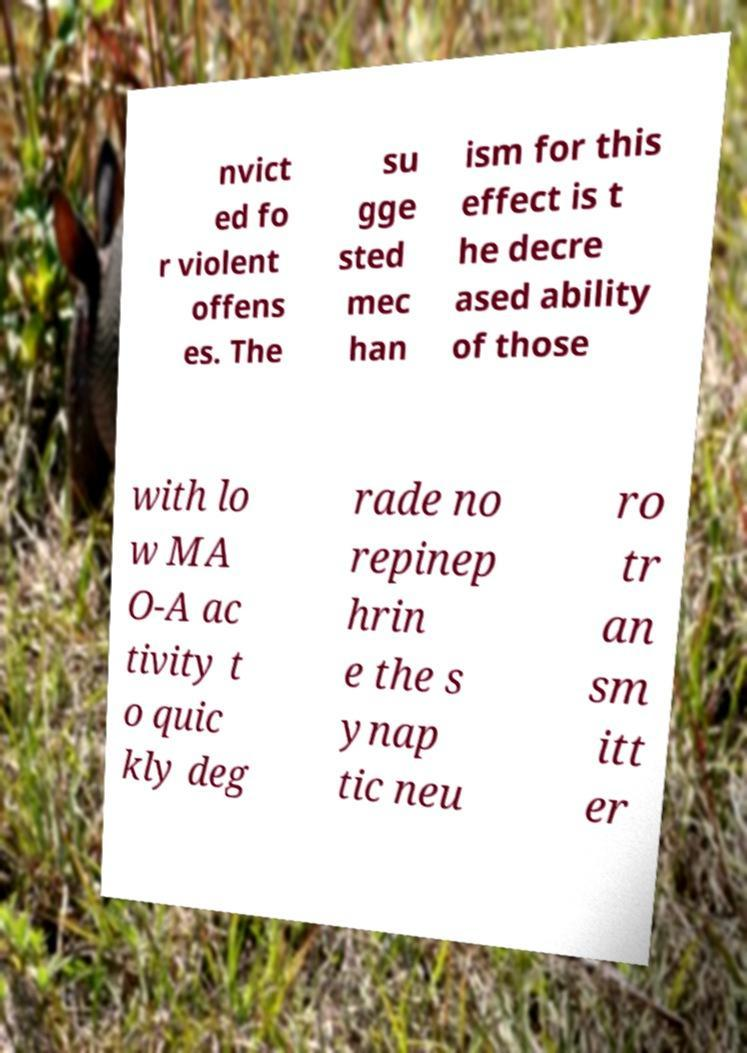For documentation purposes, I need the text within this image transcribed. Could you provide that? nvict ed fo r violent offens es. The su gge sted mec han ism for this effect is t he decre ased ability of those with lo w MA O-A ac tivity t o quic kly deg rade no repinep hrin e the s ynap tic neu ro tr an sm itt er 